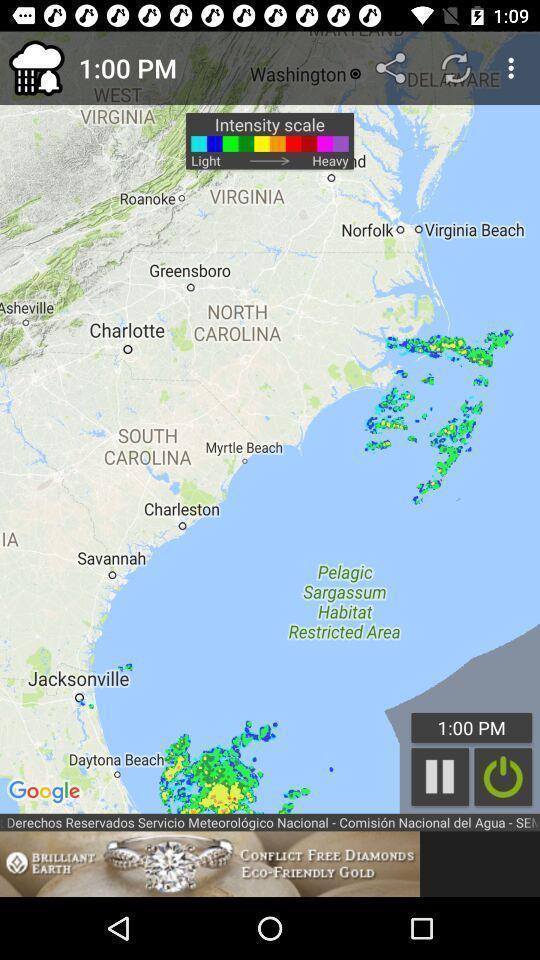Describe this image in words. Page showing map in a weather app. 